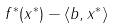<formula> <loc_0><loc_0><loc_500><loc_500>f ^ { * } ( x ^ { * } ) - \langle b , x ^ { * } \rangle</formula> 